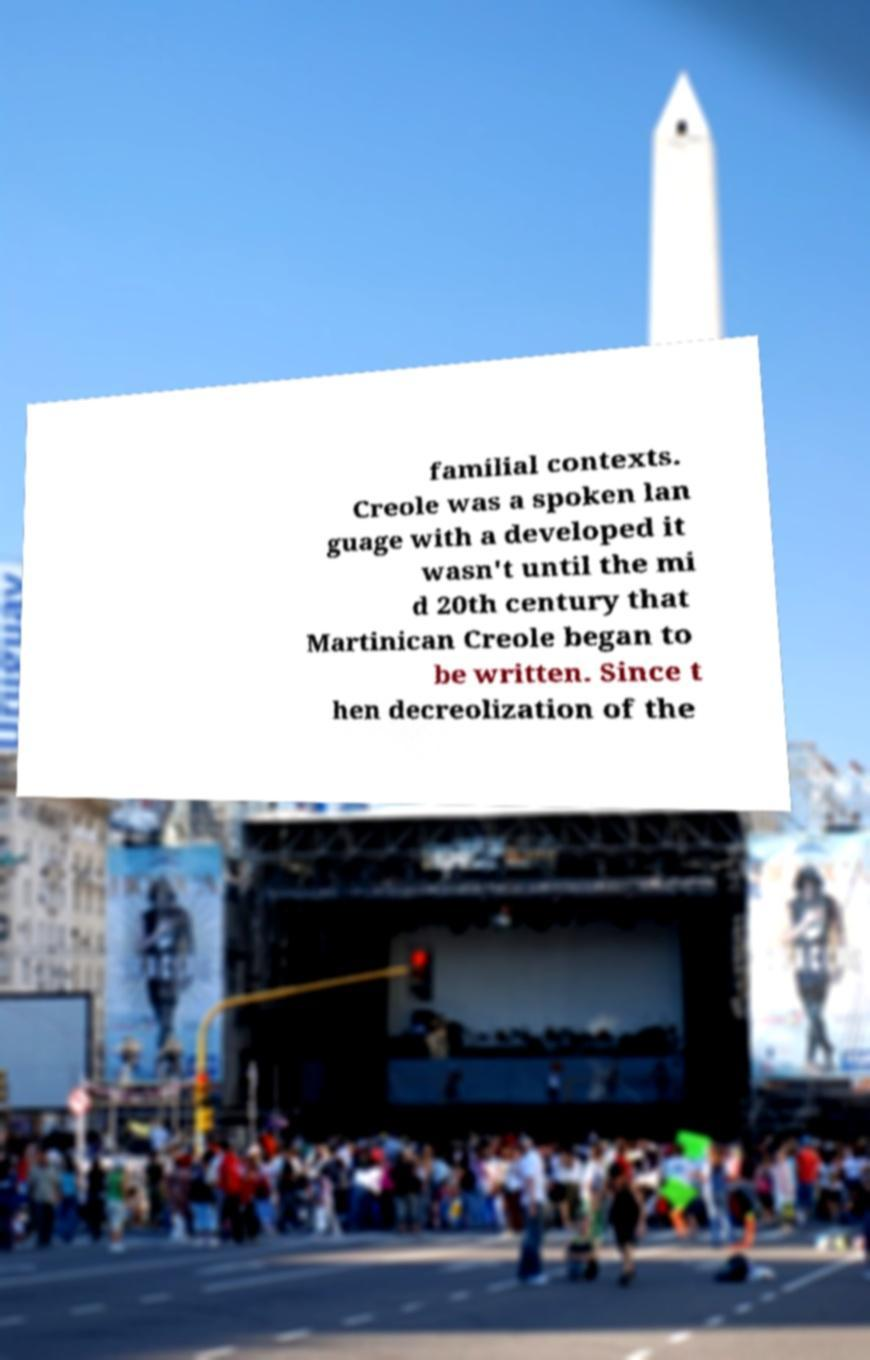There's text embedded in this image that I need extracted. Can you transcribe it verbatim? familial contexts. Creole was a spoken lan guage with a developed it wasn't until the mi d 20th century that Martinican Creole began to be written. Since t hen decreolization of the 